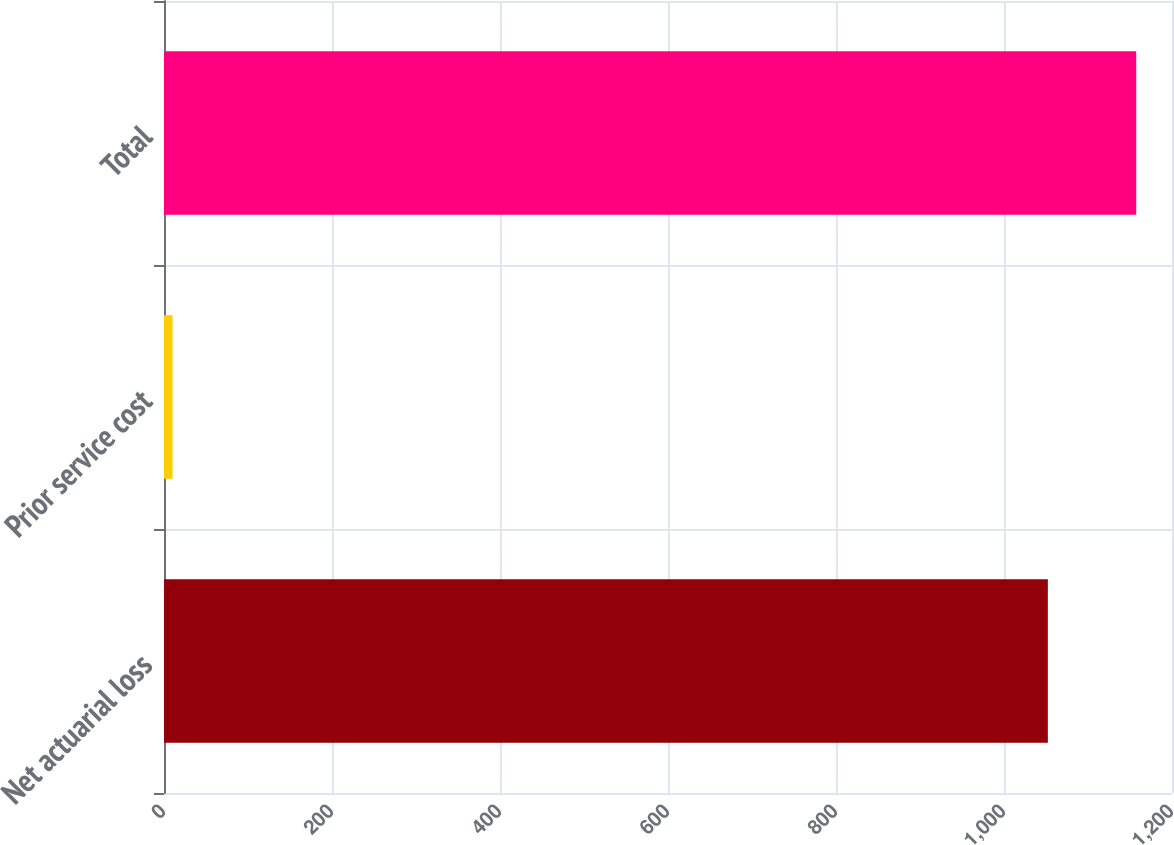Convert chart to OTSL. <chart><loc_0><loc_0><loc_500><loc_500><bar_chart><fcel>Net actuarial loss<fcel>Prior service cost<fcel>Total<nl><fcel>1052.2<fcel>10.1<fcel>1157.42<nl></chart> 